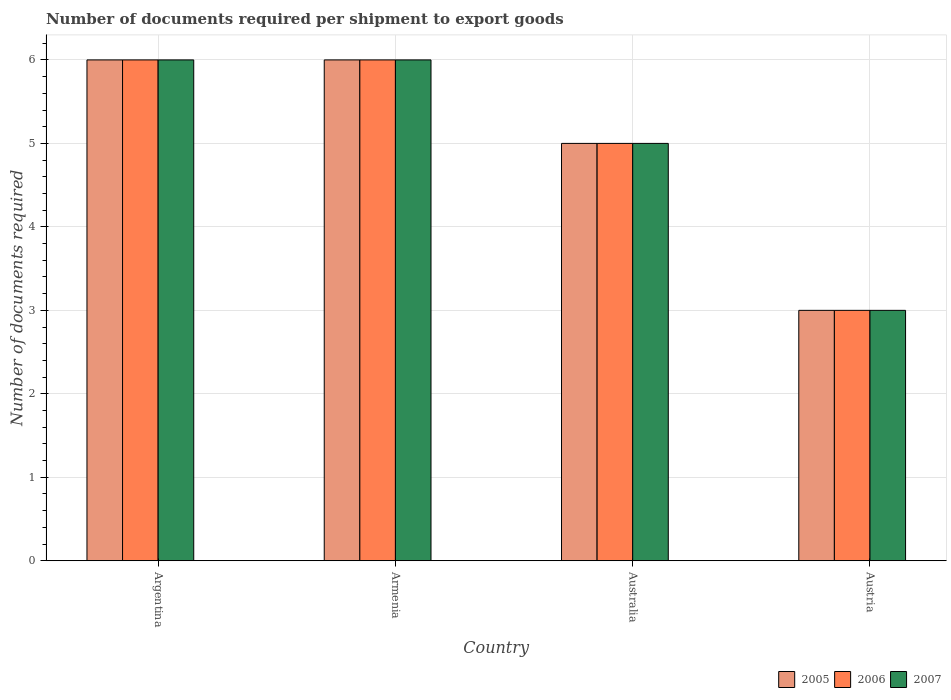How many different coloured bars are there?
Offer a very short reply. 3. Are the number of bars per tick equal to the number of legend labels?
Provide a short and direct response. Yes. Are the number of bars on each tick of the X-axis equal?
Your answer should be very brief. Yes. How many bars are there on the 1st tick from the left?
Your response must be concise. 3. What is the label of the 2nd group of bars from the left?
Offer a very short reply. Armenia. What is the total number of documents required per shipment to export goods in 2005 in the graph?
Keep it short and to the point. 20. What is the difference between the number of documents required per shipment to export goods in 2006 in Austria and the number of documents required per shipment to export goods in 2005 in Argentina?
Your response must be concise. -3. What is the difference between the number of documents required per shipment to export goods of/in 2006 and number of documents required per shipment to export goods of/in 2005 in Armenia?
Provide a short and direct response. 0. Is the difference between the number of documents required per shipment to export goods in 2006 in Australia and Austria greater than the difference between the number of documents required per shipment to export goods in 2005 in Australia and Austria?
Provide a short and direct response. No. What is the difference between the highest and the lowest number of documents required per shipment to export goods in 2006?
Make the answer very short. 3. What does the 2nd bar from the left in Australia represents?
Your response must be concise. 2006. Is it the case that in every country, the sum of the number of documents required per shipment to export goods in 2006 and number of documents required per shipment to export goods in 2005 is greater than the number of documents required per shipment to export goods in 2007?
Make the answer very short. Yes. How many bars are there?
Give a very brief answer. 12. Are all the bars in the graph horizontal?
Your answer should be compact. No. How many countries are there in the graph?
Ensure brevity in your answer.  4. What is the difference between two consecutive major ticks on the Y-axis?
Make the answer very short. 1. What is the title of the graph?
Offer a very short reply. Number of documents required per shipment to export goods. What is the label or title of the X-axis?
Give a very brief answer. Country. What is the label or title of the Y-axis?
Keep it short and to the point. Number of documents required. What is the Number of documents required in 2005 in Argentina?
Your answer should be compact. 6. What is the Number of documents required of 2006 in Argentina?
Give a very brief answer. 6. What is the Number of documents required of 2007 in Argentina?
Your answer should be very brief. 6. What is the Number of documents required in 2006 in Armenia?
Give a very brief answer. 6. What is the Number of documents required of 2007 in Armenia?
Give a very brief answer. 6. What is the Number of documents required of 2006 in Australia?
Make the answer very short. 5. What is the Number of documents required in 2006 in Austria?
Provide a succinct answer. 3. Across all countries, what is the maximum Number of documents required in 2006?
Give a very brief answer. 6. Across all countries, what is the maximum Number of documents required of 2007?
Make the answer very short. 6. Across all countries, what is the minimum Number of documents required of 2006?
Provide a short and direct response. 3. What is the total Number of documents required in 2005 in the graph?
Offer a very short reply. 20. What is the total Number of documents required in 2006 in the graph?
Give a very brief answer. 20. What is the difference between the Number of documents required of 2006 in Argentina and that in Armenia?
Ensure brevity in your answer.  0. What is the difference between the Number of documents required in 2005 in Argentina and that in Australia?
Your answer should be compact. 1. What is the difference between the Number of documents required in 2007 in Argentina and that in Australia?
Offer a terse response. 1. What is the difference between the Number of documents required in 2005 in Argentina and that in Austria?
Ensure brevity in your answer.  3. What is the difference between the Number of documents required of 2007 in Argentina and that in Austria?
Provide a short and direct response. 3. What is the difference between the Number of documents required in 2007 in Armenia and that in Australia?
Your answer should be very brief. 1. What is the difference between the Number of documents required of 2005 in Armenia and that in Austria?
Offer a terse response. 3. What is the difference between the Number of documents required of 2007 in Armenia and that in Austria?
Your answer should be very brief. 3. What is the difference between the Number of documents required in 2005 in Australia and that in Austria?
Offer a very short reply. 2. What is the difference between the Number of documents required in 2007 in Australia and that in Austria?
Your answer should be compact. 2. What is the difference between the Number of documents required of 2005 in Argentina and the Number of documents required of 2006 in Armenia?
Give a very brief answer. 0. What is the difference between the Number of documents required of 2006 in Argentina and the Number of documents required of 2007 in Armenia?
Your answer should be compact. 0. What is the difference between the Number of documents required in 2005 in Argentina and the Number of documents required in 2006 in Australia?
Provide a short and direct response. 1. What is the difference between the Number of documents required in 2006 in Argentina and the Number of documents required in 2007 in Australia?
Give a very brief answer. 1. What is the difference between the Number of documents required in 2005 in Argentina and the Number of documents required in 2006 in Austria?
Your response must be concise. 3. What is the difference between the Number of documents required in 2005 in Argentina and the Number of documents required in 2007 in Austria?
Give a very brief answer. 3. What is the difference between the Number of documents required in 2005 in Armenia and the Number of documents required in 2006 in Australia?
Offer a terse response. 1. What is the difference between the Number of documents required in 2005 in Armenia and the Number of documents required in 2007 in Australia?
Offer a terse response. 1. What is the difference between the Number of documents required in 2006 in Armenia and the Number of documents required in 2007 in Australia?
Ensure brevity in your answer.  1. What is the difference between the Number of documents required in 2005 in Armenia and the Number of documents required in 2007 in Austria?
Give a very brief answer. 3. What is the difference between the Number of documents required in 2006 in Armenia and the Number of documents required in 2007 in Austria?
Ensure brevity in your answer.  3. What is the difference between the Number of documents required of 2005 in Australia and the Number of documents required of 2006 in Austria?
Provide a short and direct response. 2. What is the difference between the Number of documents required of 2005 in Australia and the Number of documents required of 2007 in Austria?
Give a very brief answer. 2. What is the average Number of documents required of 2006 per country?
Ensure brevity in your answer.  5. What is the average Number of documents required of 2007 per country?
Your answer should be very brief. 5. What is the difference between the Number of documents required of 2005 and Number of documents required of 2006 in Armenia?
Keep it short and to the point. 0. What is the difference between the Number of documents required in 2005 and Number of documents required in 2007 in Armenia?
Your answer should be very brief. 0. What is the difference between the Number of documents required in 2006 and Number of documents required in 2007 in Armenia?
Offer a very short reply. 0. What is the difference between the Number of documents required in 2005 and Number of documents required in 2006 in Australia?
Provide a short and direct response. 0. What is the difference between the Number of documents required of 2005 and Number of documents required of 2007 in Australia?
Offer a terse response. 0. What is the difference between the Number of documents required in 2005 and Number of documents required in 2006 in Austria?
Keep it short and to the point. 0. What is the difference between the Number of documents required of 2005 and Number of documents required of 2007 in Austria?
Keep it short and to the point. 0. What is the ratio of the Number of documents required of 2005 in Argentina to that in Armenia?
Offer a very short reply. 1. What is the ratio of the Number of documents required of 2006 in Argentina to that in Armenia?
Your answer should be very brief. 1. What is the ratio of the Number of documents required of 2007 in Argentina to that in Armenia?
Keep it short and to the point. 1. What is the ratio of the Number of documents required in 2005 in Argentina to that in Australia?
Give a very brief answer. 1.2. What is the ratio of the Number of documents required of 2006 in Argentina to that in Austria?
Give a very brief answer. 2. What is the ratio of the Number of documents required in 2007 in Argentina to that in Austria?
Offer a very short reply. 2. What is the ratio of the Number of documents required in 2005 in Armenia to that in Australia?
Offer a very short reply. 1.2. What is the ratio of the Number of documents required in 2007 in Armenia to that in Austria?
Your answer should be very brief. 2. What is the ratio of the Number of documents required of 2006 in Australia to that in Austria?
Your answer should be compact. 1.67. What is the difference between the highest and the lowest Number of documents required in 2006?
Make the answer very short. 3. 